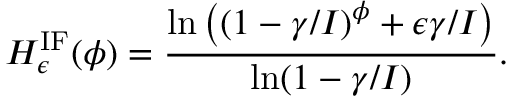<formula> <loc_0><loc_0><loc_500><loc_500>H _ { \epsilon } ^ { I F } ( \phi ) = \frac { \ln \left ( ( 1 - \gamma / I ) ^ { \phi } + \epsilon \gamma / I \right ) } { \ln ( 1 - \gamma / I ) } .</formula> 